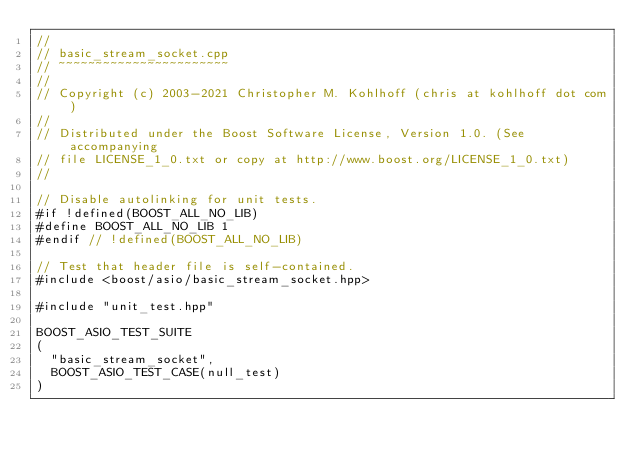<code> <loc_0><loc_0><loc_500><loc_500><_C++_>//
// basic_stream_socket.cpp
// ~~~~~~~~~~~~~~~~~~~~~~~
//
// Copyright (c) 2003-2021 Christopher M. Kohlhoff (chris at kohlhoff dot com)
//
// Distributed under the Boost Software License, Version 1.0. (See accompanying
// file LICENSE_1_0.txt or copy at http://www.boost.org/LICENSE_1_0.txt)
//

// Disable autolinking for unit tests.
#if !defined(BOOST_ALL_NO_LIB)
#define BOOST_ALL_NO_LIB 1
#endif // !defined(BOOST_ALL_NO_LIB)

// Test that header file is self-contained.
#include <boost/asio/basic_stream_socket.hpp>

#include "unit_test.hpp"

BOOST_ASIO_TEST_SUITE
(
  "basic_stream_socket",
  BOOST_ASIO_TEST_CASE(null_test)
)
</code> 